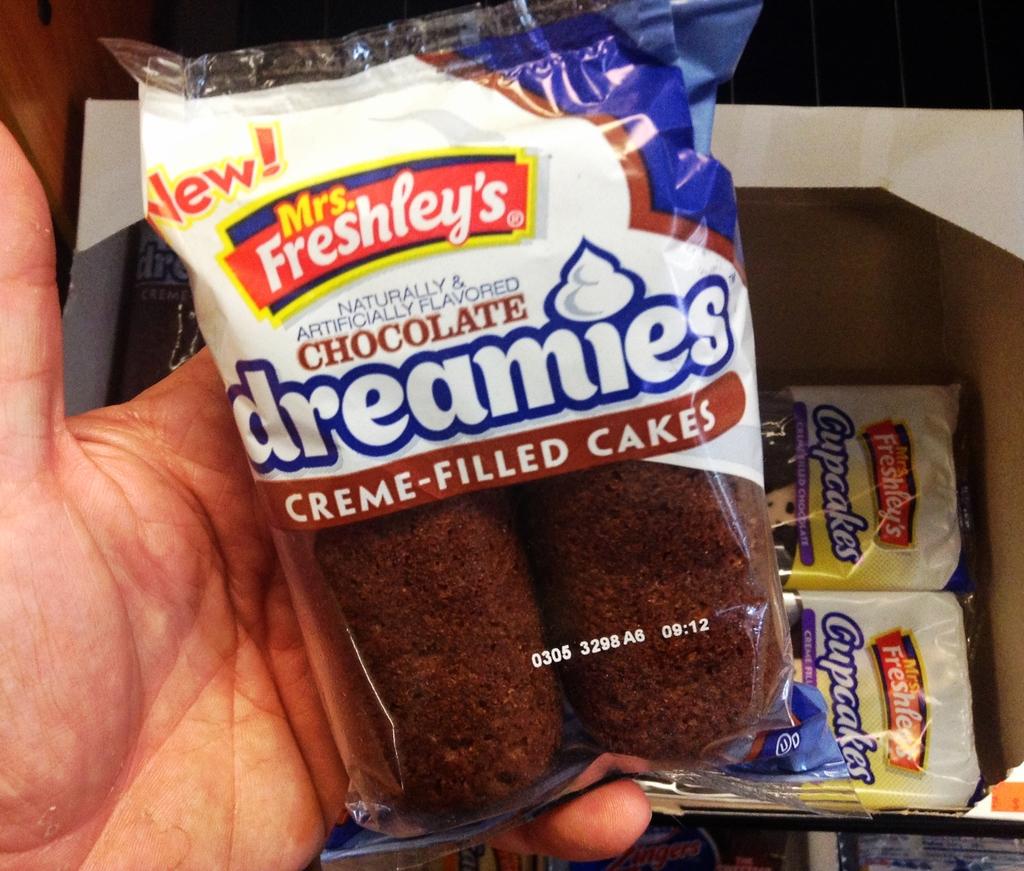What is the brand name of this snack?
Make the answer very short. Mrs. freshley's. 